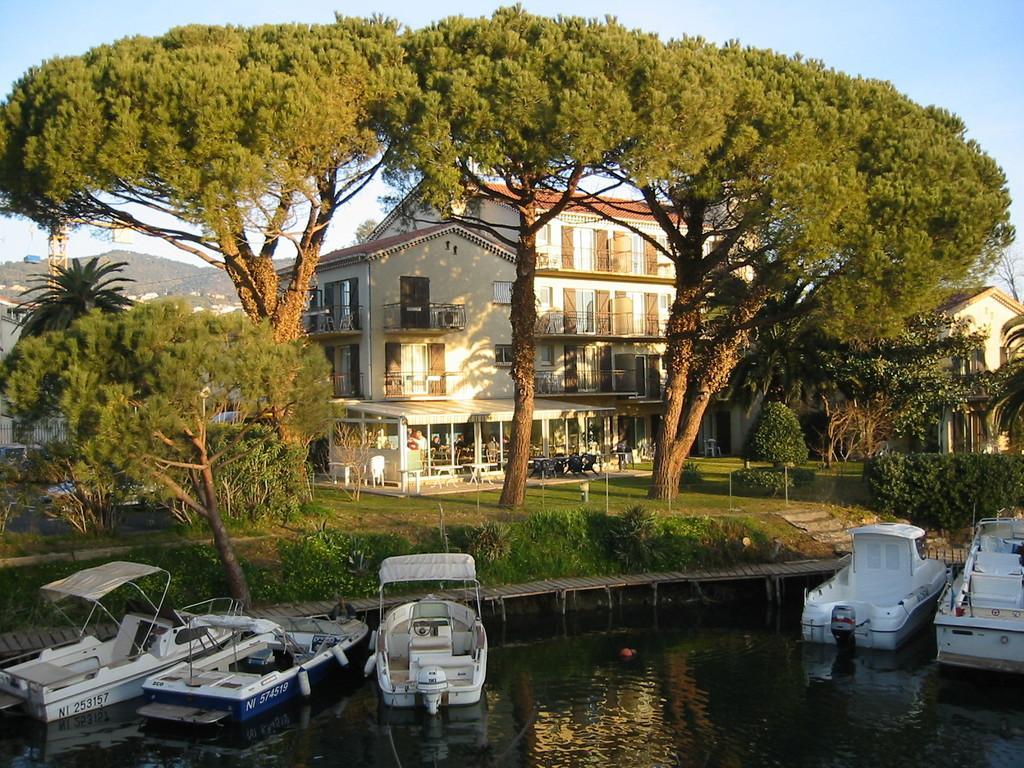Can you describe this image briefly? In this picture we can see water at the bottom, there are some boats here, in the background there is a building, we can see grass and trees here, there is the sky at the top of the picture. 